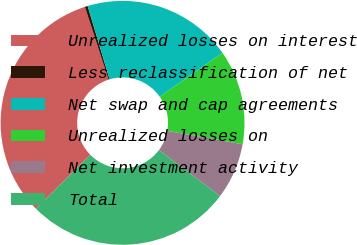Convert chart. <chart><loc_0><loc_0><loc_500><loc_500><pie_chart><fcel>Unrealized losses on interest<fcel>Less reclassification of net<fcel>Net swap and cap agreements<fcel>Unrealized losses on<fcel>Net investment activity<fcel>Total<nl><fcel>32.42%<fcel>0.38%<fcel>19.89%<fcel>12.54%<fcel>7.44%<fcel>27.33%<nl></chart> 